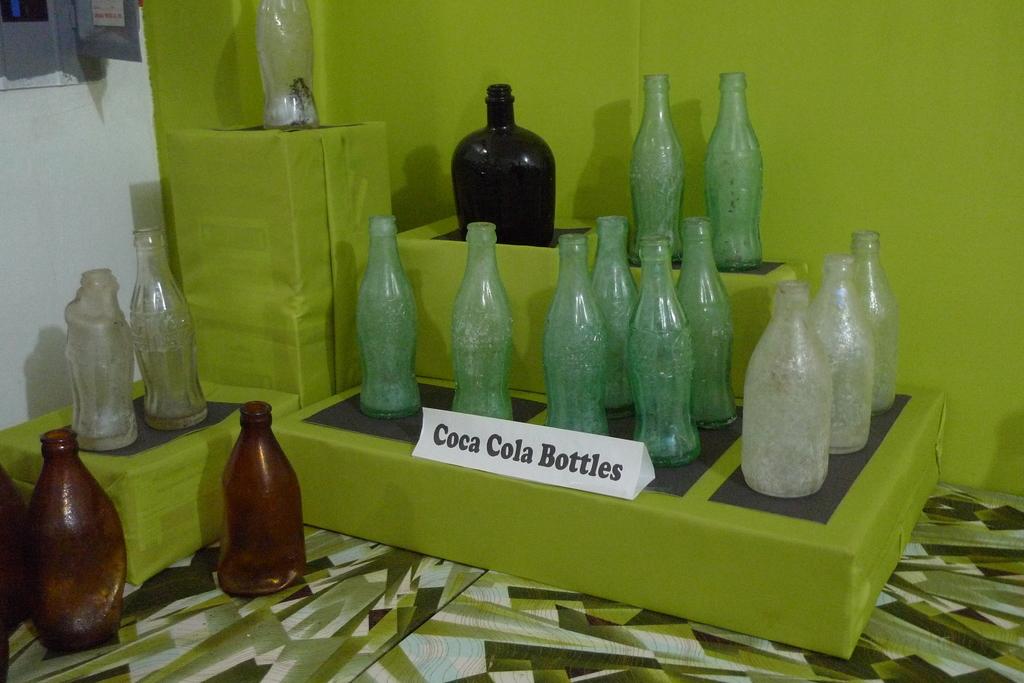What are these items?
Keep it short and to the point. Coca cola bottles. What kind of bottles?
Your answer should be compact. Coca cola. 